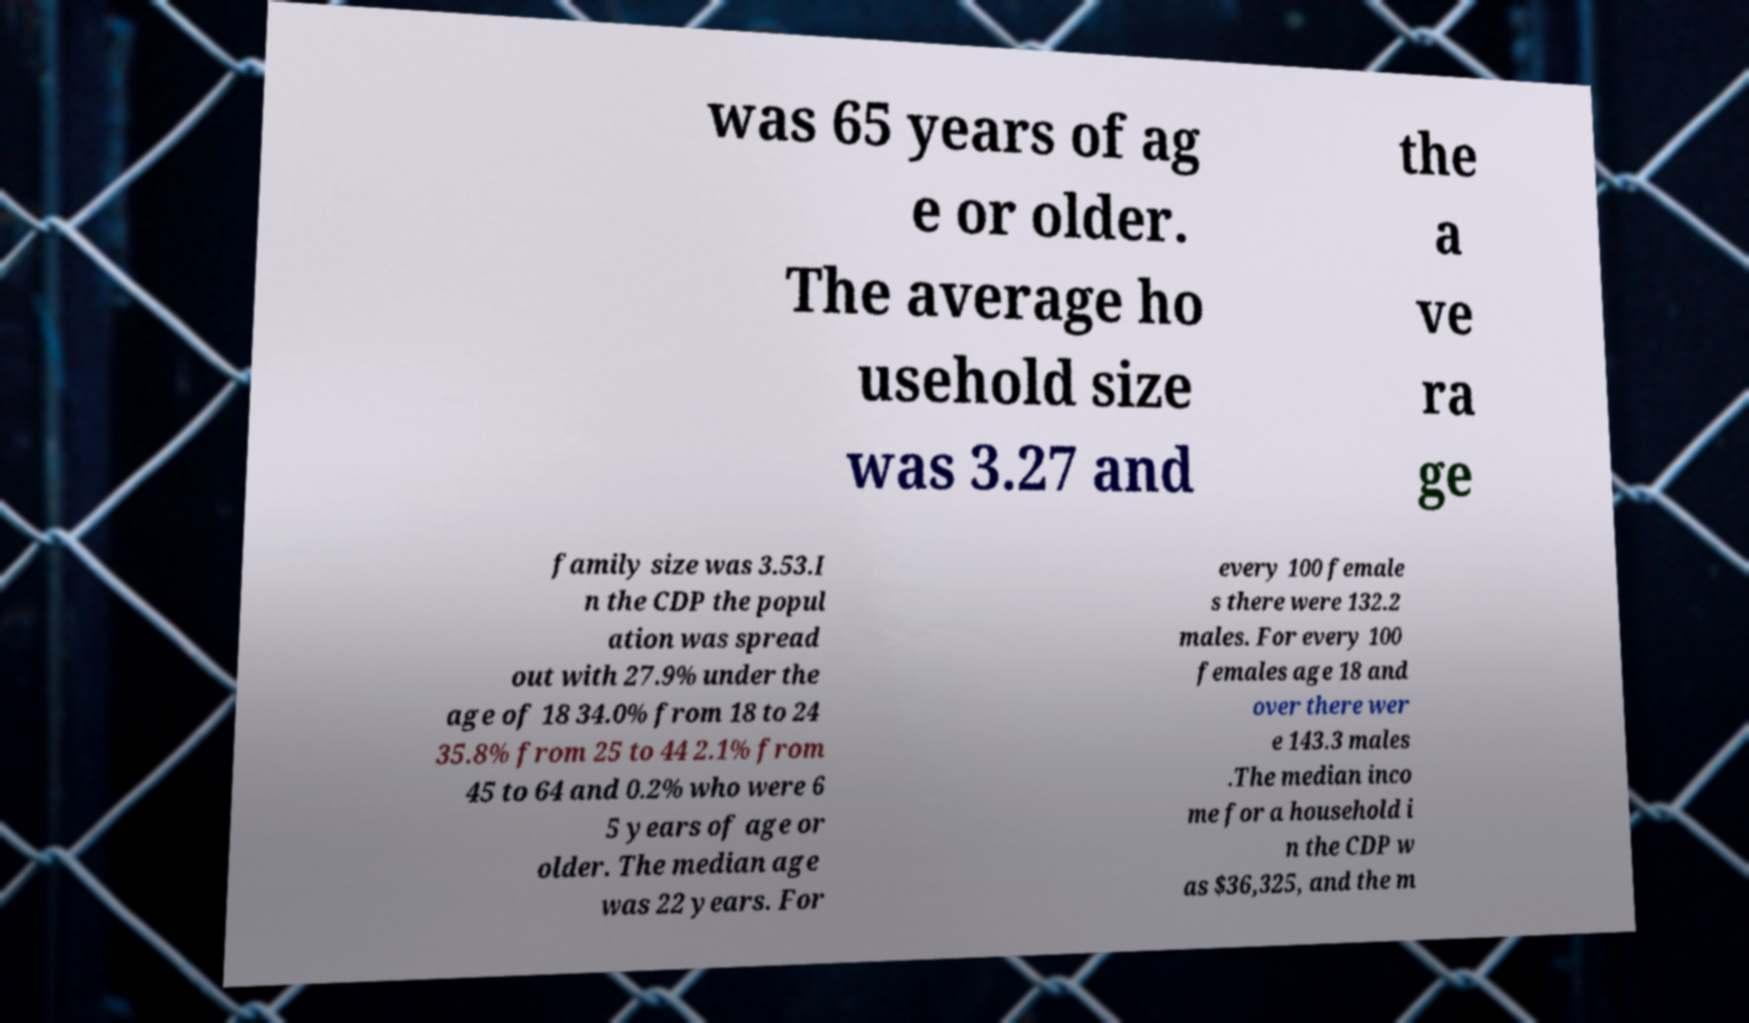Can you accurately transcribe the text from the provided image for me? was 65 years of ag e or older. The average ho usehold size was 3.27 and the a ve ra ge family size was 3.53.I n the CDP the popul ation was spread out with 27.9% under the age of 18 34.0% from 18 to 24 35.8% from 25 to 44 2.1% from 45 to 64 and 0.2% who were 6 5 years of age or older. The median age was 22 years. For every 100 female s there were 132.2 males. For every 100 females age 18 and over there wer e 143.3 males .The median inco me for a household i n the CDP w as $36,325, and the m 